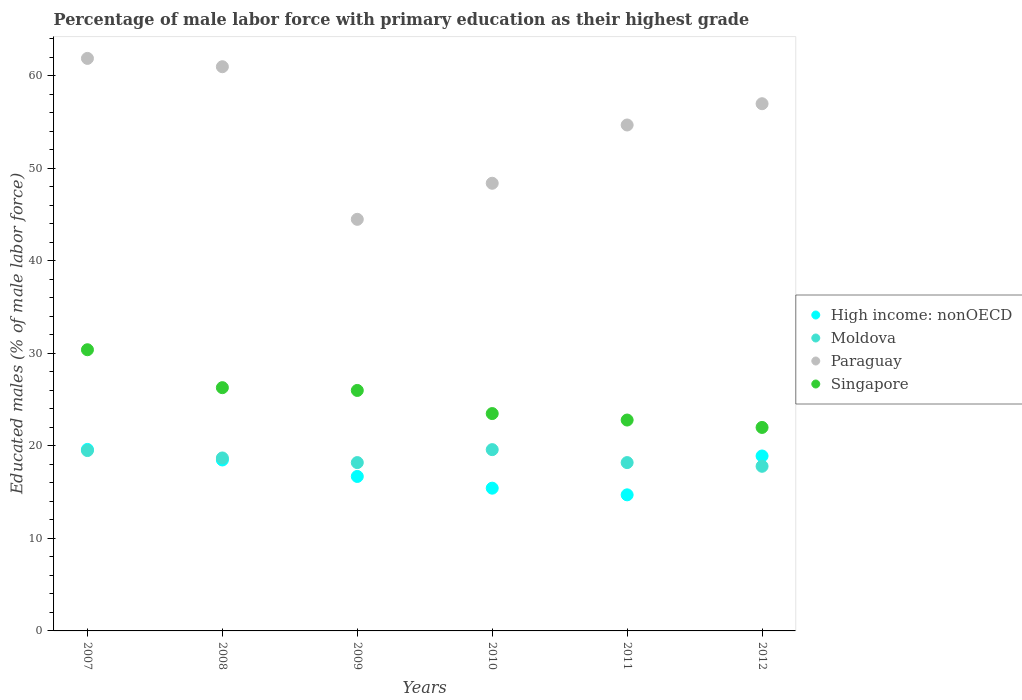How many different coloured dotlines are there?
Keep it short and to the point. 4. What is the percentage of male labor force with primary education in Singapore in 2012?
Your answer should be very brief. 22. Across all years, what is the maximum percentage of male labor force with primary education in Paraguay?
Keep it short and to the point. 61.9. Across all years, what is the minimum percentage of male labor force with primary education in Paraguay?
Provide a short and direct response. 44.5. In which year was the percentage of male labor force with primary education in Singapore maximum?
Your response must be concise. 2007. In which year was the percentage of male labor force with primary education in Paraguay minimum?
Provide a succinct answer. 2009. What is the total percentage of male labor force with primary education in Singapore in the graph?
Ensure brevity in your answer.  151. What is the difference between the percentage of male labor force with primary education in High income: nonOECD in 2007 and that in 2009?
Give a very brief answer. 2.92. What is the difference between the percentage of male labor force with primary education in Singapore in 2010 and the percentage of male labor force with primary education in Moldova in 2012?
Provide a succinct answer. 5.7. What is the average percentage of male labor force with primary education in Moldova per year?
Ensure brevity in your answer.  18.67. In the year 2008, what is the difference between the percentage of male labor force with primary education in Moldova and percentage of male labor force with primary education in High income: nonOECD?
Your answer should be very brief. 0.22. What is the ratio of the percentage of male labor force with primary education in Moldova in 2009 to that in 2010?
Offer a very short reply. 0.93. Is the difference between the percentage of male labor force with primary education in Moldova in 2008 and 2010 greater than the difference between the percentage of male labor force with primary education in High income: nonOECD in 2008 and 2010?
Your response must be concise. No. What is the difference between the highest and the second highest percentage of male labor force with primary education in Moldova?
Your answer should be very brief. 0.1. What is the difference between the highest and the lowest percentage of male labor force with primary education in High income: nonOECD?
Offer a terse response. 4.91. In how many years, is the percentage of male labor force with primary education in High income: nonOECD greater than the average percentage of male labor force with primary education in High income: nonOECD taken over all years?
Your answer should be very brief. 3. Is it the case that in every year, the sum of the percentage of male labor force with primary education in Paraguay and percentage of male labor force with primary education in Singapore  is greater than the sum of percentage of male labor force with primary education in Moldova and percentage of male labor force with primary education in High income: nonOECD?
Your response must be concise. Yes. Is it the case that in every year, the sum of the percentage of male labor force with primary education in Singapore and percentage of male labor force with primary education in Paraguay  is greater than the percentage of male labor force with primary education in High income: nonOECD?
Provide a short and direct response. Yes. Is the percentage of male labor force with primary education in High income: nonOECD strictly greater than the percentage of male labor force with primary education in Singapore over the years?
Give a very brief answer. No. Is the percentage of male labor force with primary education in Singapore strictly less than the percentage of male labor force with primary education in Moldova over the years?
Your answer should be very brief. No. How many years are there in the graph?
Give a very brief answer. 6. What is the difference between two consecutive major ticks on the Y-axis?
Keep it short and to the point. 10. Are the values on the major ticks of Y-axis written in scientific E-notation?
Your answer should be very brief. No. Does the graph contain grids?
Your response must be concise. No. Where does the legend appear in the graph?
Offer a very short reply. Center right. How many legend labels are there?
Offer a terse response. 4. How are the legend labels stacked?
Offer a terse response. Vertical. What is the title of the graph?
Make the answer very short. Percentage of male labor force with primary education as their highest grade. Does "Burkina Faso" appear as one of the legend labels in the graph?
Offer a very short reply. No. What is the label or title of the X-axis?
Give a very brief answer. Years. What is the label or title of the Y-axis?
Provide a short and direct response. Educated males (% of male labor force). What is the Educated males (% of male labor force) of High income: nonOECD in 2007?
Provide a short and direct response. 19.62. What is the Educated males (% of male labor force) of Moldova in 2007?
Your answer should be very brief. 19.5. What is the Educated males (% of male labor force) of Paraguay in 2007?
Offer a very short reply. 61.9. What is the Educated males (% of male labor force) of Singapore in 2007?
Offer a terse response. 30.4. What is the Educated males (% of male labor force) of High income: nonOECD in 2008?
Your answer should be very brief. 18.48. What is the Educated males (% of male labor force) of Moldova in 2008?
Offer a very short reply. 18.7. What is the Educated males (% of male labor force) in Singapore in 2008?
Your answer should be very brief. 26.3. What is the Educated males (% of male labor force) in High income: nonOECD in 2009?
Your response must be concise. 16.7. What is the Educated males (% of male labor force) of Moldova in 2009?
Ensure brevity in your answer.  18.2. What is the Educated males (% of male labor force) in Paraguay in 2009?
Provide a short and direct response. 44.5. What is the Educated males (% of male labor force) in Singapore in 2009?
Keep it short and to the point. 26. What is the Educated males (% of male labor force) in High income: nonOECD in 2010?
Your answer should be compact. 15.43. What is the Educated males (% of male labor force) in Moldova in 2010?
Provide a short and direct response. 19.6. What is the Educated males (% of male labor force) of Paraguay in 2010?
Make the answer very short. 48.4. What is the Educated males (% of male labor force) of Singapore in 2010?
Offer a terse response. 23.5. What is the Educated males (% of male labor force) in High income: nonOECD in 2011?
Keep it short and to the point. 14.71. What is the Educated males (% of male labor force) in Moldova in 2011?
Provide a succinct answer. 18.2. What is the Educated males (% of male labor force) in Paraguay in 2011?
Provide a short and direct response. 54.7. What is the Educated males (% of male labor force) in Singapore in 2011?
Your response must be concise. 22.8. What is the Educated males (% of male labor force) in High income: nonOECD in 2012?
Your response must be concise. 18.91. What is the Educated males (% of male labor force) in Moldova in 2012?
Give a very brief answer. 17.8. What is the Educated males (% of male labor force) of Singapore in 2012?
Your response must be concise. 22. Across all years, what is the maximum Educated males (% of male labor force) in High income: nonOECD?
Offer a very short reply. 19.62. Across all years, what is the maximum Educated males (% of male labor force) in Moldova?
Your answer should be very brief. 19.6. Across all years, what is the maximum Educated males (% of male labor force) of Paraguay?
Offer a very short reply. 61.9. Across all years, what is the maximum Educated males (% of male labor force) in Singapore?
Make the answer very short. 30.4. Across all years, what is the minimum Educated males (% of male labor force) of High income: nonOECD?
Offer a terse response. 14.71. Across all years, what is the minimum Educated males (% of male labor force) in Moldova?
Offer a terse response. 17.8. Across all years, what is the minimum Educated males (% of male labor force) in Paraguay?
Give a very brief answer. 44.5. Across all years, what is the minimum Educated males (% of male labor force) of Singapore?
Offer a terse response. 22. What is the total Educated males (% of male labor force) of High income: nonOECD in the graph?
Provide a short and direct response. 103.87. What is the total Educated males (% of male labor force) of Moldova in the graph?
Your response must be concise. 112. What is the total Educated males (% of male labor force) in Paraguay in the graph?
Your response must be concise. 327.5. What is the total Educated males (% of male labor force) of Singapore in the graph?
Make the answer very short. 151. What is the difference between the Educated males (% of male labor force) of High income: nonOECD in 2007 and that in 2008?
Your answer should be very brief. 1.14. What is the difference between the Educated males (% of male labor force) of Moldova in 2007 and that in 2008?
Offer a terse response. 0.8. What is the difference between the Educated males (% of male labor force) in Singapore in 2007 and that in 2008?
Ensure brevity in your answer.  4.1. What is the difference between the Educated males (% of male labor force) of High income: nonOECD in 2007 and that in 2009?
Give a very brief answer. 2.92. What is the difference between the Educated males (% of male labor force) of Moldova in 2007 and that in 2009?
Offer a terse response. 1.3. What is the difference between the Educated males (% of male labor force) of Singapore in 2007 and that in 2009?
Provide a short and direct response. 4.4. What is the difference between the Educated males (% of male labor force) in High income: nonOECD in 2007 and that in 2010?
Offer a very short reply. 4.19. What is the difference between the Educated males (% of male labor force) in High income: nonOECD in 2007 and that in 2011?
Ensure brevity in your answer.  4.91. What is the difference between the Educated males (% of male labor force) in Moldova in 2007 and that in 2011?
Keep it short and to the point. 1.3. What is the difference between the Educated males (% of male labor force) in Paraguay in 2007 and that in 2011?
Make the answer very short. 7.2. What is the difference between the Educated males (% of male labor force) in High income: nonOECD in 2007 and that in 2012?
Offer a very short reply. 0.71. What is the difference between the Educated males (% of male labor force) of Paraguay in 2007 and that in 2012?
Make the answer very short. 4.9. What is the difference between the Educated males (% of male labor force) in High income: nonOECD in 2008 and that in 2009?
Make the answer very short. 1.78. What is the difference between the Educated males (% of male labor force) of Paraguay in 2008 and that in 2009?
Provide a succinct answer. 16.5. What is the difference between the Educated males (% of male labor force) in Singapore in 2008 and that in 2009?
Make the answer very short. 0.3. What is the difference between the Educated males (% of male labor force) in High income: nonOECD in 2008 and that in 2010?
Offer a terse response. 3.05. What is the difference between the Educated males (% of male labor force) in High income: nonOECD in 2008 and that in 2011?
Make the answer very short. 3.77. What is the difference between the Educated males (% of male labor force) in Paraguay in 2008 and that in 2011?
Keep it short and to the point. 6.3. What is the difference between the Educated males (% of male labor force) in Singapore in 2008 and that in 2011?
Your response must be concise. 3.5. What is the difference between the Educated males (% of male labor force) of High income: nonOECD in 2008 and that in 2012?
Your response must be concise. -0.43. What is the difference between the Educated males (% of male labor force) in Moldova in 2008 and that in 2012?
Give a very brief answer. 0.9. What is the difference between the Educated males (% of male labor force) in Paraguay in 2008 and that in 2012?
Your response must be concise. 4. What is the difference between the Educated males (% of male labor force) of High income: nonOECD in 2009 and that in 2010?
Your answer should be very brief. 1.27. What is the difference between the Educated males (% of male labor force) in Moldova in 2009 and that in 2010?
Keep it short and to the point. -1.4. What is the difference between the Educated males (% of male labor force) in Singapore in 2009 and that in 2010?
Ensure brevity in your answer.  2.5. What is the difference between the Educated males (% of male labor force) of High income: nonOECD in 2009 and that in 2011?
Your answer should be very brief. 1.99. What is the difference between the Educated males (% of male labor force) in Moldova in 2009 and that in 2011?
Give a very brief answer. 0. What is the difference between the Educated males (% of male labor force) of Singapore in 2009 and that in 2011?
Offer a terse response. 3.2. What is the difference between the Educated males (% of male labor force) of High income: nonOECD in 2009 and that in 2012?
Provide a succinct answer. -2.21. What is the difference between the Educated males (% of male labor force) of Moldova in 2009 and that in 2012?
Keep it short and to the point. 0.4. What is the difference between the Educated males (% of male labor force) in Paraguay in 2009 and that in 2012?
Ensure brevity in your answer.  -12.5. What is the difference between the Educated males (% of male labor force) in Singapore in 2009 and that in 2012?
Keep it short and to the point. 4. What is the difference between the Educated males (% of male labor force) of High income: nonOECD in 2010 and that in 2011?
Your response must be concise. 0.72. What is the difference between the Educated males (% of male labor force) of Moldova in 2010 and that in 2011?
Ensure brevity in your answer.  1.4. What is the difference between the Educated males (% of male labor force) in High income: nonOECD in 2010 and that in 2012?
Your answer should be compact. -3.48. What is the difference between the Educated males (% of male labor force) of Paraguay in 2010 and that in 2012?
Provide a succinct answer. -8.6. What is the difference between the Educated males (% of male labor force) in Singapore in 2010 and that in 2012?
Your answer should be compact. 1.5. What is the difference between the Educated males (% of male labor force) of High income: nonOECD in 2011 and that in 2012?
Your response must be concise. -4.2. What is the difference between the Educated males (% of male labor force) in Moldova in 2011 and that in 2012?
Give a very brief answer. 0.4. What is the difference between the Educated males (% of male labor force) in High income: nonOECD in 2007 and the Educated males (% of male labor force) in Moldova in 2008?
Give a very brief answer. 0.92. What is the difference between the Educated males (% of male labor force) of High income: nonOECD in 2007 and the Educated males (% of male labor force) of Paraguay in 2008?
Ensure brevity in your answer.  -41.38. What is the difference between the Educated males (% of male labor force) of High income: nonOECD in 2007 and the Educated males (% of male labor force) of Singapore in 2008?
Give a very brief answer. -6.68. What is the difference between the Educated males (% of male labor force) of Moldova in 2007 and the Educated males (% of male labor force) of Paraguay in 2008?
Ensure brevity in your answer.  -41.5. What is the difference between the Educated males (% of male labor force) of Moldova in 2007 and the Educated males (% of male labor force) of Singapore in 2008?
Your answer should be very brief. -6.8. What is the difference between the Educated males (% of male labor force) of Paraguay in 2007 and the Educated males (% of male labor force) of Singapore in 2008?
Make the answer very short. 35.6. What is the difference between the Educated males (% of male labor force) in High income: nonOECD in 2007 and the Educated males (% of male labor force) in Moldova in 2009?
Provide a succinct answer. 1.42. What is the difference between the Educated males (% of male labor force) in High income: nonOECD in 2007 and the Educated males (% of male labor force) in Paraguay in 2009?
Your answer should be very brief. -24.88. What is the difference between the Educated males (% of male labor force) in High income: nonOECD in 2007 and the Educated males (% of male labor force) in Singapore in 2009?
Offer a terse response. -6.38. What is the difference between the Educated males (% of male labor force) of Moldova in 2007 and the Educated males (% of male labor force) of Paraguay in 2009?
Provide a short and direct response. -25. What is the difference between the Educated males (% of male labor force) of Paraguay in 2007 and the Educated males (% of male labor force) of Singapore in 2009?
Give a very brief answer. 35.9. What is the difference between the Educated males (% of male labor force) of High income: nonOECD in 2007 and the Educated males (% of male labor force) of Moldova in 2010?
Give a very brief answer. 0.02. What is the difference between the Educated males (% of male labor force) of High income: nonOECD in 2007 and the Educated males (% of male labor force) of Paraguay in 2010?
Offer a very short reply. -28.78. What is the difference between the Educated males (% of male labor force) in High income: nonOECD in 2007 and the Educated males (% of male labor force) in Singapore in 2010?
Provide a short and direct response. -3.88. What is the difference between the Educated males (% of male labor force) in Moldova in 2007 and the Educated males (% of male labor force) in Paraguay in 2010?
Your answer should be very brief. -28.9. What is the difference between the Educated males (% of male labor force) of Moldova in 2007 and the Educated males (% of male labor force) of Singapore in 2010?
Your response must be concise. -4. What is the difference between the Educated males (% of male labor force) of Paraguay in 2007 and the Educated males (% of male labor force) of Singapore in 2010?
Keep it short and to the point. 38.4. What is the difference between the Educated males (% of male labor force) of High income: nonOECD in 2007 and the Educated males (% of male labor force) of Moldova in 2011?
Give a very brief answer. 1.42. What is the difference between the Educated males (% of male labor force) of High income: nonOECD in 2007 and the Educated males (% of male labor force) of Paraguay in 2011?
Ensure brevity in your answer.  -35.08. What is the difference between the Educated males (% of male labor force) of High income: nonOECD in 2007 and the Educated males (% of male labor force) of Singapore in 2011?
Make the answer very short. -3.18. What is the difference between the Educated males (% of male labor force) of Moldova in 2007 and the Educated males (% of male labor force) of Paraguay in 2011?
Ensure brevity in your answer.  -35.2. What is the difference between the Educated males (% of male labor force) in Moldova in 2007 and the Educated males (% of male labor force) in Singapore in 2011?
Give a very brief answer. -3.3. What is the difference between the Educated males (% of male labor force) in Paraguay in 2007 and the Educated males (% of male labor force) in Singapore in 2011?
Make the answer very short. 39.1. What is the difference between the Educated males (% of male labor force) in High income: nonOECD in 2007 and the Educated males (% of male labor force) in Moldova in 2012?
Provide a succinct answer. 1.82. What is the difference between the Educated males (% of male labor force) of High income: nonOECD in 2007 and the Educated males (% of male labor force) of Paraguay in 2012?
Offer a very short reply. -37.38. What is the difference between the Educated males (% of male labor force) of High income: nonOECD in 2007 and the Educated males (% of male labor force) of Singapore in 2012?
Your answer should be compact. -2.38. What is the difference between the Educated males (% of male labor force) of Moldova in 2007 and the Educated males (% of male labor force) of Paraguay in 2012?
Your answer should be compact. -37.5. What is the difference between the Educated males (% of male labor force) of Paraguay in 2007 and the Educated males (% of male labor force) of Singapore in 2012?
Provide a short and direct response. 39.9. What is the difference between the Educated males (% of male labor force) of High income: nonOECD in 2008 and the Educated males (% of male labor force) of Moldova in 2009?
Your response must be concise. 0.28. What is the difference between the Educated males (% of male labor force) in High income: nonOECD in 2008 and the Educated males (% of male labor force) in Paraguay in 2009?
Ensure brevity in your answer.  -26.02. What is the difference between the Educated males (% of male labor force) of High income: nonOECD in 2008 and the Educated males (% of male labor force) of Singapore in 2009?
Provide a succinct answer. -7.52. What is the difference between the Educated males (% of male labor force) in Moldova in 2008 and the Educated males (% of male labor force) in Paraguay in 2009?
Your response must be concise. -25.8. What is the difference between the Educated males (% of male labor force) in Moldova in 2008 and the Educated males (% of male labor force) in Singapore in 2009?
Make the answer very short. -7.3. What is the difference between the Educated males (% of male labor force) of Paraguay in 2008 and the Educated males (% of male labor force) of Singapore in 2009?
Keep it short and to the point. 35. What is the difference between the Educated males (% of male labor force) in High income: nonOECD in 2008 and the Educated males (% of male labor force) in Moldova in 2010?
Ensure brevity in your answer.  -1.12. What is the difference between the Educated males (% of male labor force) of High income: nonOECD in 2008 and the Educated males (% of male labor force) of Paraguay in 2010?
Your answer should be very brief. -29.92. What is the difference between the Educated males (% of male labor force) of High income: nonOECD in 2008 and the Educated males (% of male labor force) of Singapore in 2010?
Provide a short and direct response. -5.02. What is the difference between the Educated males (% of male labor force) of Moldova in 2008 and the Educated males (% of male labor force) of Paraguay in 2010?
Make the answer very short. -29.7. What is the difference between the Educated males (% of male labor force) of Moldova in 2008 and the Educated males (% of male labor force) of Singapore in 2010?
Provide a succinct answer. -4.8. What is the difference between the Educated males (% of male labor force) of Paraguay in 2008 and the Educated males (% of male labor force) of Singapore in 2010?
Your response must be concise. 37.5. What is the difference between the Educated males (% of male labor force) in High income: nonOECD in 2008 and the Educated males (% of male labor force) in Moldova in 2011?
Provide a short and direct response. 0.28. What is the difference between the Educated males (% of male labor force) of High income: nonOECD in 2008 and the Educated males (% of male labor force) of Paraguay in 2011?
Your answer should be very brief. -36.22. What is the difference between the Educated males (% of male labor force) in High income: nonOECD in 2008 and the Educated males (% of male labor force) in Singapore in 2011?
Provide a succinct answer. -4.32. What is the difference between the Educated males (% of male labor force) in Moldova in 2008 and the Educated males (% of male labor force) in Paraguay in 2011?
Keep it short and to the point. -36. What is the difference between the Educated males (% of male labor force) in Moldova in 2008 and the Educated males (% of male labor force) in Singapore in 2011?
Provide a succinct answer. -4.1. What is the difference between the Educated males (% of male labor force) of Paraguay in 2008 and the Educated males (% of male labor force) of Singapore in 2011?
Ensure brevity in your answer.  38.2. What is the difference between the Educated males (% of male labor force) of High income: nonOECD in 2008 and the Educated males (% of male labor force) of Moldova in 2012?
Give a very brief answer. 0.68. What is the difference between the Educated males (% of male labor force) of High income: nonOECD in 2008 and the Educated males (% of male labor force) of Paraguay in 2012?
Provide a succinct answer. -38.52. What is the difference between the Educated males (% of male labor force) in High income: nonOECD in 2008 and the Educated males (% of male labor force) in Singapore in 2012?
Offer a terse response. -3.52. What is the difference between the Educated males (% of male labor force) in Moldova in 2008 and the Educated males (% of male labor force) in Paraguay in 2012?
Your answer should be compact. -38.3. What is the difference between the Educated males (% of male labor force) of Moldova in 2008 and the Educated males (% of male labor force) of Singapore in 2012?
Offer a very short reply. -3.3. What is the difference between the Educated males (% of male labor force) of Paraguay in 2008 and the Educated males (% of male labor force) of Singapore in 2012?
Offer a terse response. 39. What is the difference between the Educated males (% of male labor force) in High income: nonOECD in 2009 and the Educated males (% of male labor force) in Moldova in 2010?
Give a very brief answer. -2.9. What is the difference between the Educated males (% of male labor force) in High income: nonOECD in 2009 and the Educated males (% of male labor force) in Paraguay in 2010?
Your answer should be very brief. -31.7. What is the difference between the Educated males (% of male labor force) in High income: nonOECD in 2009 and the Educated males (% of male labor force) in Singapore in 2010?
Offer a very short reply. -6.8. What is the difference between the Educated males (% of male labor force) of Moldova in 2009 and the Educated males (% of male labor force) of Paraguay in 2010?
Ensure brevity in your answer.  -30.2. What is the difference between the Educated males (% of male labor force) of Moldova in 2009 and the Educated males (% of male labor force) of Singapore in 2010?
Provide a short and direct response. -5.3. What is the difference between the Educated males (% of male labor force) in High income: nonOECD in 2009 and the Educated males (% of male labor force) in Moldova in 2011?
Offer a very short reply. -1.5. What is the difference between the Educated males (% of male labor force) in High income: nonOECD in 2009 and the Educated males (% of male labor force) in Paraguay in 2011?
Make the answer very short. -38. What is the difference between the Educated males (% of male labor force) in High income: nonOECD in 2009 and the Educated males (% of male labor force) in Singapore in 2011?
Offer a terse response. -6.1. What is the difference between the Educated males (% of male labor force) of Moldova in 2009 and the Educated males (% of male labor force) of Paraguay in 2011?
Your answer should be compact. -36.5. What is the difference between the Educated males (% of male labor force) in Paraguay in 2009 and the Educated males (% of male labor force) in Singapore in 2011?
Your response must be concise. 21.7. What is the difference between the Educated males (% of male labor force) in High income: nonOECD in 2009 and the Educated males (% of male labor force) in Moldova in 2012?
Provide a short and direct response. -1.1. What is the difference between the Educated males (% of male labor force) in High income: nonOECD in 2009 and the Educated males (% of male labor force) in Paraguay in 2012?
Offer a very short reply. -40.3. What is the difference between the Educated males (% of male labor force) of High income: nonOECD in 2009 and the Educated males (% of male labor force) of Singapore in 2012?
Provide a succinct answer. -5.3. What is the difference between the Educated males (% of male labor force) of Moldova in 2009 and the Educated males (% of male labor force) of Paraguay in 2012?
Your response must be concise. -38.8. What is the difference between the Educated males (% of male labor force) of Moldova in 2009 and the Educated males (% of male labor force) of Singapore in 2012?
Your answer should be very brief. -3.8. What is the difference between the Educated males (% of male labor force) of High income: nonOECD in 2010 and the Educated males (% of male labor force) of Moldova in 2011?
Provide a short and direct response. -2.77. What is the difference between the Educated males (% of male labor force) of High income: nonOECD in 2010 and the Educated males (% of male labor force) of Paraguay in 2011?
Your response must be concise. -39.27. What is the difference between the Educated males (% of male labor force) in High income: nonOECD in 2010 and the Educated males (% of male labor force) in Singapore in 2011?
Your response must be concise. -7.37. What is the difference between the Educated males (% of male labor force) of Moldova in 2010 and the Educated males (% of male labor force) of Paraguay in 2011?
Your answer should be compact. -35.1. What is the difference between the Educated males (% of male labor force) in Moldova in 2010 and the Educated males (% of male labor force) in Singapore in 2011?
Offer a very short reply. -3.2. What is the difference between the Educated males (% of male labor force) of Paraguay in 2010 and the Educated males (% of male labor force) of Singapore in 2011?
Keep it short and to the point. 25.6. What is the difference between the Educated males (% of male labor force) of High income: nonOECD in 2010 and the Educated males (% of male labor force) of Moldova in 2012?
Your answer should be very brief. -2.37. What is the difference between the Educated males (% of male labor force) of High income: nonOECD in 2010 and the Educated males (% of male labor force) of Paraguay in 2012?
Provide a succinct answer. -41.57. What is the difference between the Educated males (% of male labor force) in High income: nonOECD in 2010 and the Educated males (% of male labor force) in Singapore in 2012?
Provide a short and direct response. -6.57. What is the difference between the Educated males (% of male labor force) of Moldova in 2010 and the Educated males (% of male labor force) of Paraguay in 2012?
Ensure brevity in your answer.  -37.4. What is the difference between the Educated males (% of male labor force) of Moldova in 2010 and the Educated males (% of male labor force) of Singapore in 2012?
Offer a terse response. -2.4. What is the difference between the Educated males (% of male labor force) of Paraguay in 2010 and the Educated males (% of male labor force) of Singapore in 2012?
Give a very brief answer. 26.4. What is the difference between the Educated males (% of male labor force) of High income: nonOECD in 2011 and the Educated males (% of male labor force) of Moldova in 2012?
Provide a short and direct response. -3.09. What is the difference between the Educated males (% of male labor force) in High income: nonOECD in 2011 and the Educated males (% of male labor force) in Paraguay in 2012?
Offer a very short reply. -42.29. What is the difference between the Educated males (% of male labor force) in High income: nonOECD in 2011 and the Educated males (% of male labor force) in Singapore in 2012?
Keep it short and to the point. -7.29. What is the difference between the Educated males (% of male labor force) in Moldova in 2011 and the Educated males (% of male labor force) in Paraguay in 2012?
Make the answer very short. -38.8. What is the difference between the Educated males (% of male labor force) of Moldova in 2011 and the Educated males (% of male labor force) of Singapore in 2012?
Your answer should be very brief. -3.8. What is the difference between the Educated males (% of male labor force) in Paraguay in 2011 and the Educated males (% of male labor force) in Singapore in 2012?
Give a very brief answer. 32.7. What is the average Educated males (% of male labor force) in High income: nonOECD per year?
Offer a very short reply. 17.31. What is the average Educated males (% of male labor force) in Moldova per year?
Give a very brief answer. 18.67. What is the average Educated males (% of male labor force) of Paraguay per year?
Give a very brief answer. 54.58. What is the average Educated males (% of male labor force) in Singapore per year?
Keep it short and to the point. 25.17. In the year 2007, what is the difference between the Educated males (% of male labor force) in High income: nonOECD and Educated males (% of male labor force) in Moldova?
Ensure brevity in your answer.  0.12. In the year 2007, what is the difference between the Educated males (% of male labor force) of High income: nonOECD and Educated males (% of male labor force) of Paraguay?
Provide a short and direct response. -42.28. In the year 2007, what is the difference between the Educated males (% of male labor force) of High income: nonOECD and Educated males (% of male labor force) of Singapore?
Make the answer very short. -10.78. In the year 2007, what is the difference between the Educated males (% of male labor force) in Moldova and Educated males (% of male labor force) in Paraguay?
Your answer should be compact. -42.4. In the year 2007, what is the difference between the Educated males (% of male labor force) of Moldova and Educated males (% of male labor force) of Singapore?
Offer a terse response. -10.9. In the year 2007, what is the difference between the Educated males (% of male labor force) of Paraguay and Educated males (% of male labor force) of Singapore?
Ensure brevity in your answer.  31.5. In the year 2008, what is the difference between the Educated males (% of male labor force) of High income: nonOECD and Educated males (% of male labor force) of Moldova?
Give a very brief answer. -0.22. In the year 2008, what is the difference between the Educated males (% of male labor force) of High income: nonOECD and Educated males (% of male labor force) of Paraguay?
Provide a short and direct response. -42.52. In the year 2008, what is the difference between the Educated males (% of male labor force) of High income: nonOECD and Educated males (% of male labor force) of Singapore?
Make the answer very short. -7.82. In the year 2008, what is the difference between the Educated males (% of male labor force) in Moldova and Educated males (% of male labor force) in Paraguay?
Provide a succinct answer. -42.3. In the year 2008, what is the difference between the Educated males (% of male labor force) in Paraguay and Educated males (% of male labor force) in Singapore?
Make the answer very short. 34.7. In the year 2009, what is the difference between the Educated males (% of male labor force) of High income: nonOECD and Educated males (% of male labor force) of Moldova?
Offer a terse response. -1.5. In the year 2009, what is the difference between the Educated males (% of male labor force) of High income: nonOECD and Educated males (% of male labor force) of Paraguay?
Your answer should be very brief. -27.8. In the year 2009, what is the difference between the Educated males (% of male labor force) in High income: nonOECD and Educated males (% of male labor force) in Singapore?
Make the answer very short. -9.3. In the year 2009, what is the difference between the Educated males (% of male labor force) in Moldova and Educated males (% of male labor force) in Paraguay?
Offer a terse response. -26.3. In the year 2010, what is the difference between the Educated males (% of male labor force) of High income: nonOECD and Educated males (% of male labor force) of Moldova?
Provide a short and direct response. -4.17. In the year 2010, what is the difference between the Educated males (% of male labor force) in High income: nonOECD and Educated males (% of male labor force) in Paraguay?
Your answer should be very brief. -32.97. In the year 2010, what is the difference between the Educated males (% of male labor force) of High income: nonOECD and Educated males (% of male labor force) of Singapore?
Offer a very short reply. -8.07. In the year 2010, what is the difference between the Educated males (% of male labor force) of Moldova and Educated males (% of male labor force) of Paraguay?
Your response must be concise. -28.8. In the year 2010, what is the difference between the Educated males (% of male labor force) in Paraguay and Educated males (% of male labor force) in Singapore?
Provide a succinct answer. 24.9. In the year 2011, what is the difference between the Educated males (% of male labor force) in High income: nonOECD and Educated males (% of male labor force) in Moldova?
Make the answer very short. -3.49. In the year 2011, what is the difference between the Educated males (% of male labor force) in High income: nonOECD and Educated males (% of male labor force) in Paraguay?
Give a very brief answer. -39.99. In the year 2011, what is the difference between the Educated males (% of male labor force) in High income: nonOECD and Educated males (% of male labor force) in Singapore?
Offer a terse response. -8.09. In the year 2011, what is the difference between the Educated males (% of male labor force) in Moldova and Educated males (% of male labor force) in Paraguay?
Make the answer very short. -36.5. In the year 2011, what is the difference between the Educated males (% of male labor force) in Paraguay and Educated males (% of male labor force) in Singapore?
Your answer should be very brief. 31.9. In the year 2012, what is the difference between the Educated males (% of male labor force) of High income: nonOECD and Educated males (% of male labor force) of Moldova?
Your response must be concise. 1.11. In the year 2012, what is the difference between the Educated males (% of male labor force) of High income: nonOECD and Educated males (% of male labor force) of Paraguay?
Offer a very short reply. -38.09. In the year 2012, what is the difference between the Educated males (% of male labor force) in High income: nonOECD and Educated males (% of male labor force) in Singapore?
Provide a succinct answer. -3.09. In the year 2012, what is the difference between the Educated males (% of male labor force) of Moldova and Educated males (% of male labor force) of Paraguay?
Give a very brief answer. -39.2. In the year 2012, what is the difference between the Educated males (% of male labor force) of Moldova and Educated males (% of male labor force) of Singapore?
Give a very brief answer. -4.2. What is the ratio of the Educated males (% of male labor force) in High income: nonOECD in 2007 to that in 2008?
Make the answer very short. 1.06. What is the ratio of the Educated males (% of male labor force) of Moldova in 2007 to that in 2008?
Your answer should be compact. 1.04. What is the ratio of the Educated males (% of male labor force) of Paraguay in 2007 to that in 2008?
Your answer should be compact. 1.01. What is the ratio of the Educated males (% of male labor force) in Singapore in 2007 to that in 2008?
Offer a terse response. 1.16. What is the ratio of the Educated males (% of male labor force) in High income: nonOECD in 2007 to that in 2009?
Offer a very short reply. 1.17. What is the ratio of the Educated males (% of male labor force) of Moldova in 2007 to that in 2009?
Ensure brevity in your answer.  1.07. What is the ratio of the Educated males (% of male labor force) of Paraguay in 2007 to that in 2009?
Keep it short and to the point. 1.39. What is the ratio of the Educated males (% of male labor force) in Singapore in 2007 to that in 2009?
Your answer should be very brief. 1.17. What is the ratio of the Educated males (% of male labor force) of High income: nonOECD in 2007 to that in 2010?
Ensure brevity in your answer.  1.27. What is the ratio of the Educated males (% of male labor force) in Moldova in 2007 to that in 2010?
Keep it short and to the point. 0.99. What is the ratio of the Educated males (% of male labor force) in Paraguay in 2007 to that in 2010?
Give a very brief answer. 1.28. What is the ratio of the Educated males (% of male labor force) of Singapore in 2007 to that in 2010?
Provide a succinct answer. 1.29. What is the ratio of the Educated males (% of male labor force) in High income: nonOECD in 2007 to that in 2011?
Provide a succinct answer. 1.33. What is the ratio of the Educated males (% of male labor force) of Moldova in 2007 to that in 2011?
Ensure brevity in your answer.  1.07. What is the ratio of the Educated males (% of male labor force) in Paraguay in 2007 to that in 2011?
Keep it short and to the point. 1.13. What is the ratio of the Educated males (% of male labor force) of Singapore in 2007 to that in 2011?
Offer a very short reply. 1.33. What is the ratio of the Educated males (% of male labor force) in High income: nonOECD in 2007 to that in 2012?
Offer a very short reply. 1.04. What is the ratio of the Educated males (% of male labor force) in Moldova in 2007 to that in 2012?
Provide a short and direct response. 1.1. What is the ratio of the Educated males (% of male labor force) of Paraguay in 2007 to that in 2012?
Your response must be concise. 1.09. What is the ratio of the Educated males (% of male labor force) in Singapore in 2007 to that in 2012?
Provide a short and direct response. 1.38. What is the ratio of the Educated males (% of male labor force) of High income: nonOECD in 2008 to that in 2009?
Give a very brief answer. 1.11. What is the ratio of the Educated males (% of male labor force) of Moldova in 2008 to that in 2009?
Provide a succinct answer. 1.03. What is the ratio of the Educated males (% of male labor force) in Paraguay in 2008 to that in 2009?
Keep it short and to the point. 1.37. What is the ratio of the Educated males (% of male labor force) in Singapore in 2008 to that in 2009?
Provide a succinct answer. 1.01. What is the ratio of the Educated males (% of male labor force) of High income: nonOECD in 2008 to that in 2010?
Your response must be concise. 1.2. What is the ratio of the Educated males (% of male labor force) in Moldova in 2008 to that in 2010?
Provide a short and direct response. 0.95. What is the ratio of the Educated males (% of male labor force) in Paraguay in 2008 to that in 2010?
Provide a short and direct response. 1.26. What is the ratio of the Educated males (% of male labor force) of Singapore in 2008 to that in 2010?
Your answer should be very brief. 1.12. What is the ratio of the Educated males (% of male labor force) of High income: nonOECD in 2008 to that in 2011?
Keep it short and to the point. 1.26. What is the ratio of the Educated males (% of male labor force) of Moldova in 2008 to that in 2011?
Provide a short and direct response. 1.03. What is the ratio of the Educated males (% of male labor force) of Paraguay in 2008 to that in 2011?
Your answer should be very brief. 1.12. What is the ratio of the Educated males (% of male labor force) of Singapore in 2008 to that in 2011?
Make the answer very short. 1.15. What is the ratio of the Educated males (% of male labor force) in High income: nonOECD in 2008 to that in 2012?
Keep it short and to the point. 0.98. What is the ratio of the Educated males (% of male labor force) of Moldova in 2008 to that in 2012?
Give a very brief answer. 1.05. What is the ratio of the Educated males (% of male labor force) in Paraguay in 2008 to that in 2012?
Your answer should be very brief. 1.07. What is the ratio of the Educated males (% of male labor force) of Singapore in 2008 to that in 2012?
Give a very brief answer. 1.2. What is the ratio of the Educated males (% of male labor force) of High income: nonOECD in 2009 to that in 2010?
Your response must be concise. 1.08. What is the ratio of the Educated males (% of male labor force) in Paraguay in 2009 to that in 2010?
Offer a terse response. 0.92. What is the ratio of the Educated males (% of male labor force) of Singapore in 2009 to that in 2010?
Keep it short and to the point. 1.11. What is the ratio of the Educated males (% of male labor force) in High income: nonOECD in 2009 to that in 2011?
Make the answer very short. 1.14. What is the ratio of the Educated males (% of male labor force) of Moldova in 2009 to that in 2011?
Give a very brief answer. 1. What is the ratio of the Educated males (% of male labor force) of Paraguay in 2009 to that in 2011?
Give a very brief answer. 0.81. What is the ratio of the Educated males (% of male labor force) in Singapore in 2009 to that in 2011?
Your answer should be compact. 1.14. What is the ratio of the Educated males (% of male labor force) of High income: nonOECD in 2009 to that in 2012?
Make the answer very short. 0.88. What is the ratio of the Educated males (% of male labor force) of Moldova in 2009 to that in 2012?
Offer a terse response. 1.02. What is the ratio of the Educated males (% of male labor force) in Paraguay in 2009 to that in 2012?
Provide a short and direct response. 0.78. What is the ratio of the Educated males (% of male labor force) in Singapore in 2009 to that in 2012?
Provide a short and direct response. 1.18. What is the ratio of the Educated males (% of male labor force) in High income: nonOECD in 2010 to that in 2011?
Ensure brevity in your answer.  1.05. What is the ratio of the Educated males (% of male labor force) in Moldova in 2010 to that in 2011?
Ensure brevity in your answer.  1.08. What is the ratio of the Educated males (% of male labor force) in Paraguay in 2010 to that in 2011?
Keep it short and to the point. 0.88. What is the ratio of the Educated males (% of male labor force) of Singapore in 2010 to that in 2011?
Keep it short and to the point. 1.03. What is the ratio of the Educated males (% of male labor force) of High income: nonOECD in 2010 to that in 2012?
Your response must be concise. 0.82. What is the ratio of the Educated males (% of male labor force) of Moldova in 2010 to that in 2012?
Ensure brevity in your answer.  1.1. What is the ratio of the Educated males (% of male labor force) of Paraguay in 2010 to that in 2012?
Keep it short and to the point. 0.85. What is the ratio of the Educated males (% of male labor force) in Singapore in 2010 to that in 2012?
Offer a very short reply. 1.07. What is the ratio of the Educated males (% of male labor force) in High income: nonOECD in 2011 to that in 2012?
Give a very brief answer. 0.78. What is the ratio of the Educated males (% of male labor force) in Moldova in 2011 to that in 2012?
Provide a succinct answer. 1.02. What is the ratio of the Educated males (% of male labor force) in Paraguay in 2011 to that in 2012?
Make the answer very short. 0.96. What is the ratio of the Educated males (% of male labor force) of Singapore in 2011 to that in 2012?
Offer a very short reply. 1.04. What is the difference between the highest and the second highest Educated males (% of male labor force) of High income: nonOECD?
Your answer should be very brief. 0.71. What is the difference between the highest and the second highest Educated males (% of male labor force) of Paraguay?
Your response must be concise. 0.9. What is the difference between the highest and the lowest Educated males (% of male labor force) of High income: nonOECD?
Provide a short and direct response. 4.91. What is the difference between the highest and the lowest Educated males (% of male labor force) in Moldova?
Make the answer very short. 1.8. What is the difference between the highest and the lowest Educated males (% of male labor force) in Paraguay?
Keep it short and to the point. 17.4. What is the difference between the highest and the lowest Educated males (% of male labor force) of Singapore?
Your answer should be very brief. 8.4. 